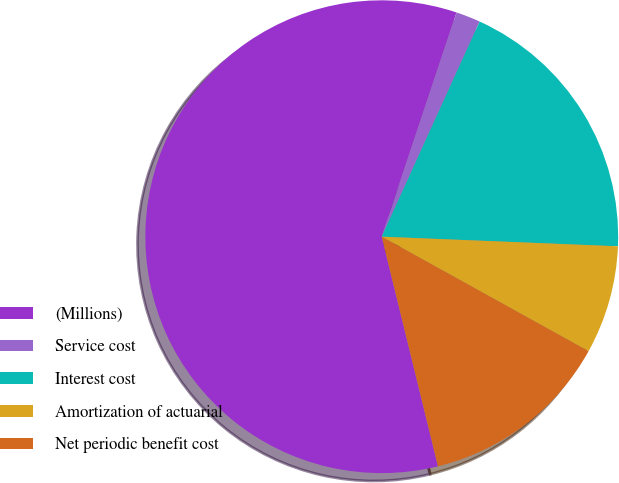<chart> <loc_0><loc_0><loc_500><loc_500><pie_chart><fcel>(Millions)<fcel>Service cost<fcel>Interest cost<fcel>Amortization of actuarial<fcel>Net periodic benefit cost<nl><fcel>58.95%<fcel>1.67%<fcel>18.85%<fcel>7.4%<fcel>13.13%<nl></chart> 